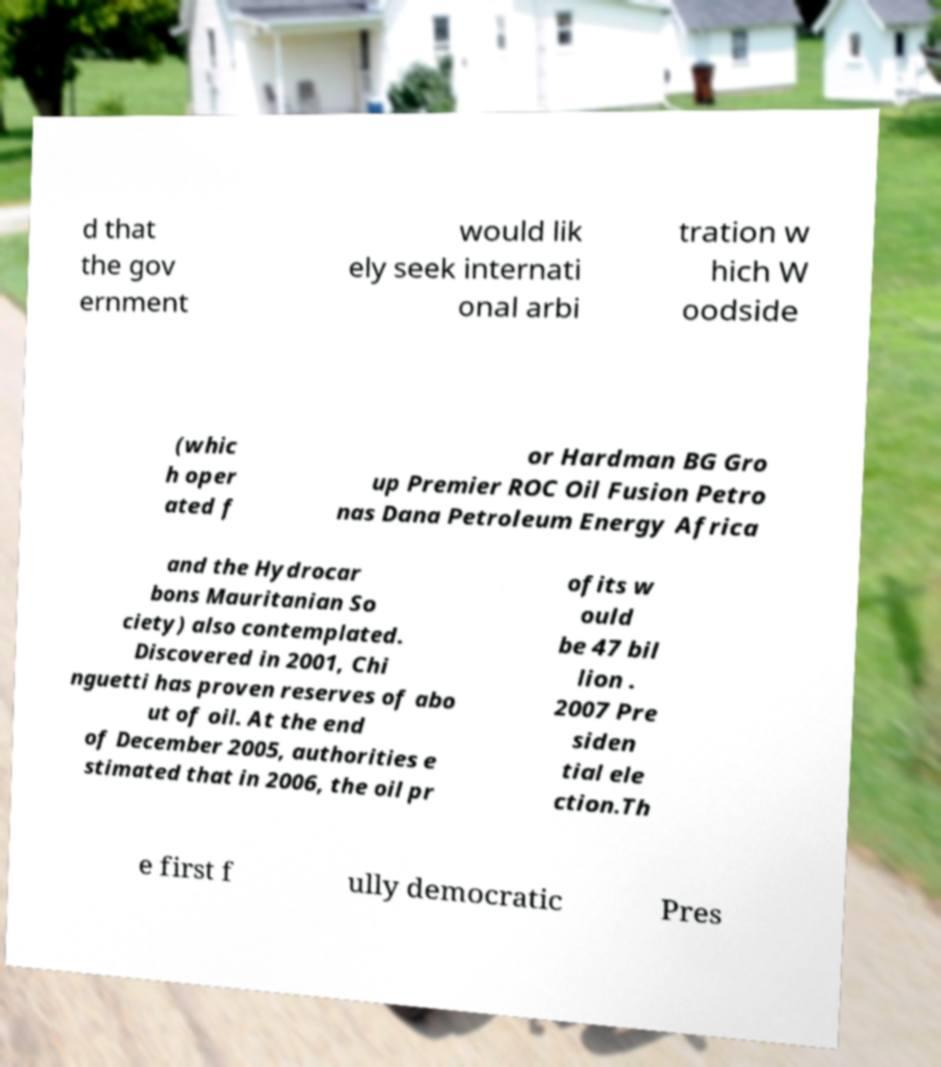What messages or text are displayed in this image? I need them in a readable, typed format. d that the gov ernment would lik ely seek internati onal arbi tration w hich W oodside (whic h oper ated f or Hardman BG Gro up Premier ROC Oil Fusion Petro nas Dana Petroleum Energy Africa and the Hydrocar bons Mauritanian So ciety) also contemplated. Discovered in 2001, Chi nguetti has proven reserves of abo ut of oil. At the end of December 2005, authorities e stimated that in 2006, the oil pr ofits w ould be 47 bil lion . 2007 Pre siden tial ele ction.Th e first f ully democratic Pres 